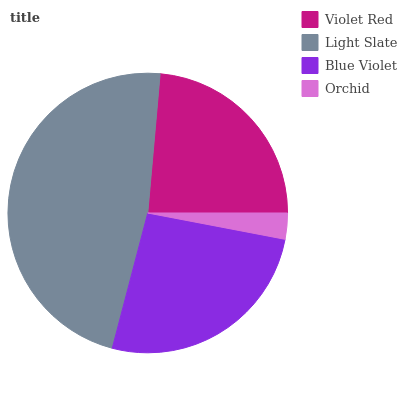Is Orchid the minimum?
Answer yes or no. Yes. Is Light Slate the maximum?
Answer yes or no. Yes. Is Blue Violet the minimum?
Answer yes or no. No. Is Blue Violet the maximum?
Answer yes or no. No. Is Light Slate greater than Blue Violet?
Answer yes or no. Yes. Is Blue Violet less than Light Slate?
Answer yes or no. Yes. Is Blue Violet greater than Light Slate?
Answer yes or no. No. Is Light Slate less than Blue Violet?
Answer yes or no. No. Is Blue Violet the high median?
Answer yes or no. Yes. Is Violet Red the low median?
Answer yes or no. Yes. Is Light Slate the high median?
Answer yes or no. No. Is Orchid the low median?
Answer yes or no. No. 